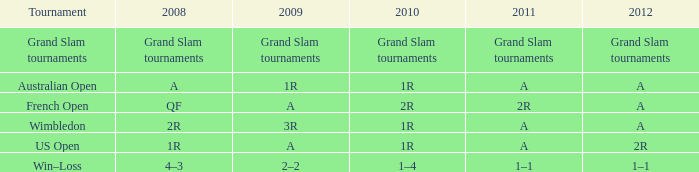Name the 2011 for 2012 of a and 2010 of 1r with 2008 of 2r A. 